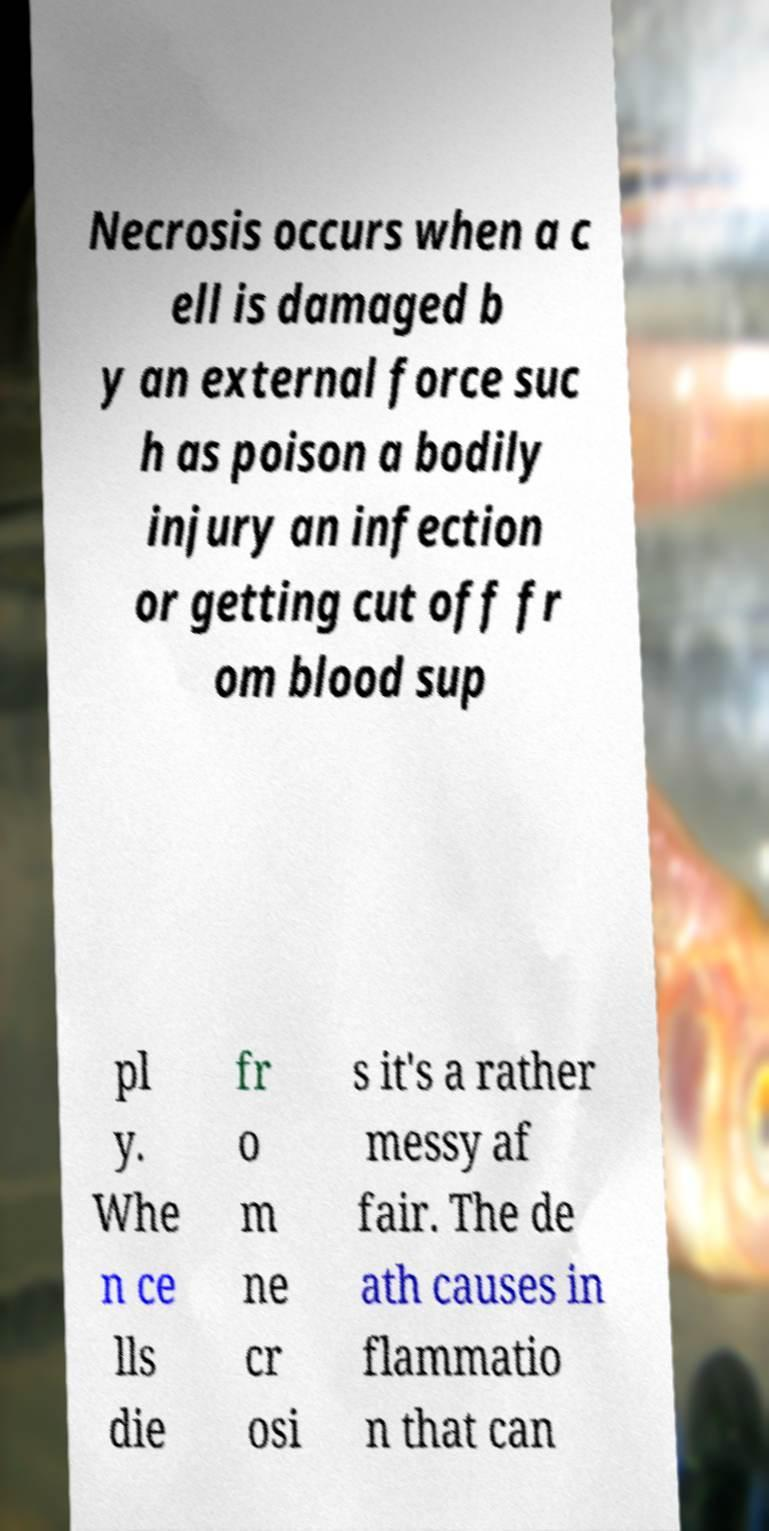What messages or text are displayed in this image? I need them in a readable, typed format. Necrosis occurs when a c ell is damaged b y an external force suc h as poison a bodily injury an infection or getting cut off fr om blood sup pl y. Whe n ce lls die fr o m ne cr osi s it's a rather messy af fair. The de ath causes in flammatio n that can 